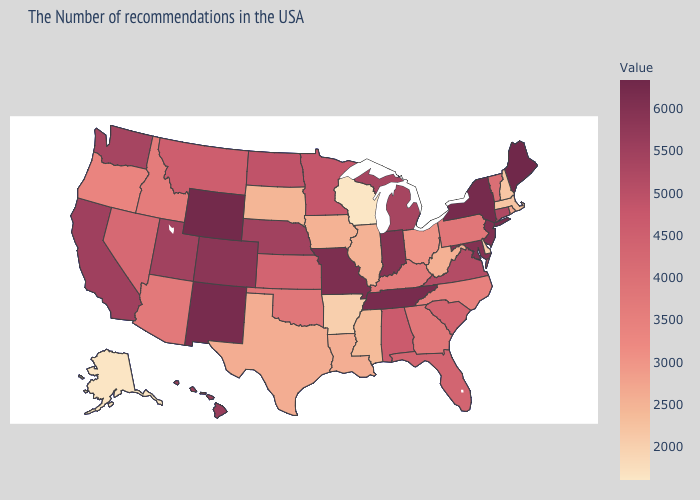Among the states that border Minnesota , does South Dakota have the highest value?
Give a very brief answer. No. Which states have the lowest value in the MidWest?
Be succinct. Wisconsin. Is the legend a continuous bar?
Be succinct. Yes. Which states have the lowest value in the MidWest?
Keep it brief. Wisconsin. Which states have the lowest value in the Northeast?
Write a very short answer. New Hampshire. Does Louisiana have the lowest value in the South?
Short answer required. No. 